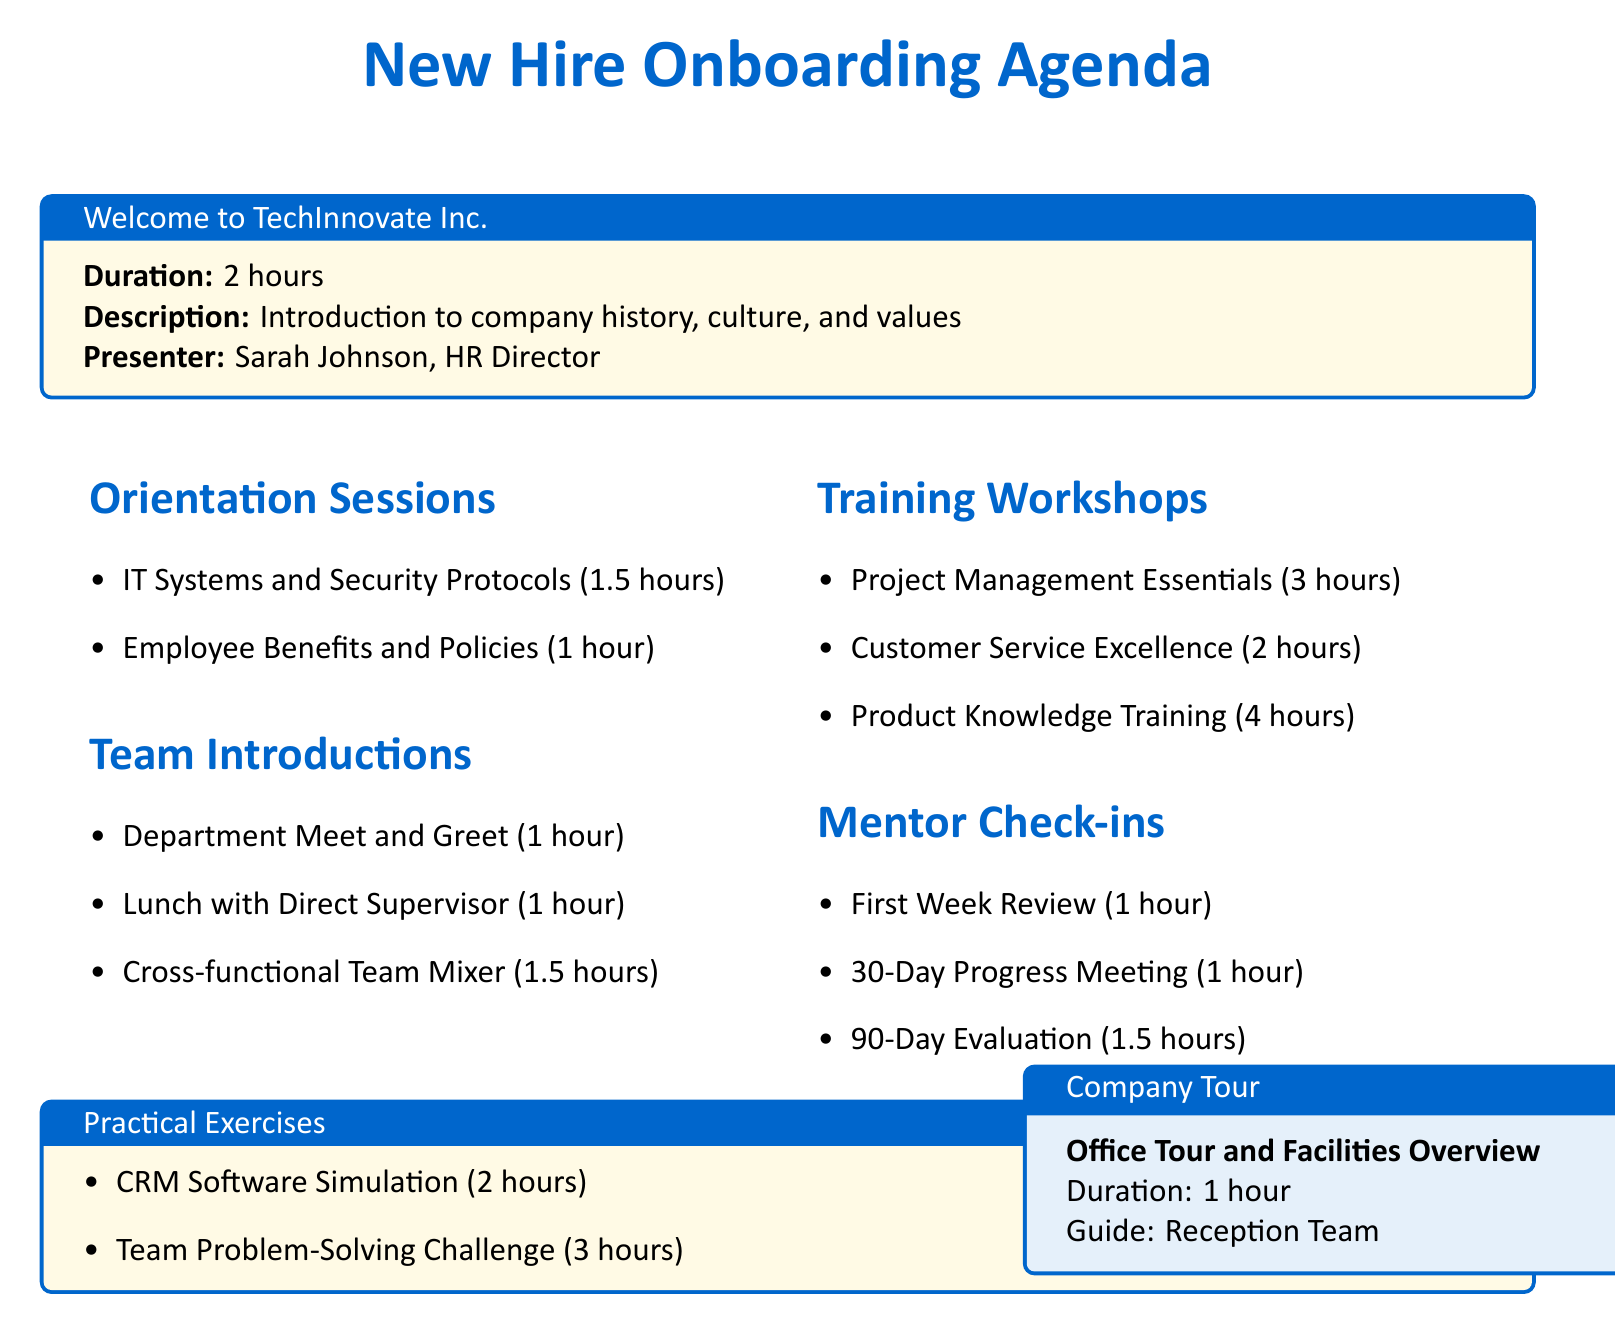What is the duration of the "Welcome to TechInnovate Inc." session? The duration of this session is stated in the document as 2 hours.
Answer: 2 hours Who is the presenter for the "IT Systems and Security Protocols"? The document specifies that Michael Chen, IT Manager, is the presenter for this session.
Answer: Michael Chen How long is the "Product Knowledge Training" workshop? The document lists its duration as 4 hours.
Answer: 4 hours What is the location for the "Lunch with Direct Supervisor"? The document states that this lunch will take place at The Green Leaf cafe.
Answer: Nearby Cafe: The Green Leaf How many mentor check-ins are scheduled in total? To find this, one can count the items listed under Mentor Check-ins, which are three: First Week Review, 30-Day Progress Meeting, and 90-Day Evaluation.
Answer: 3 